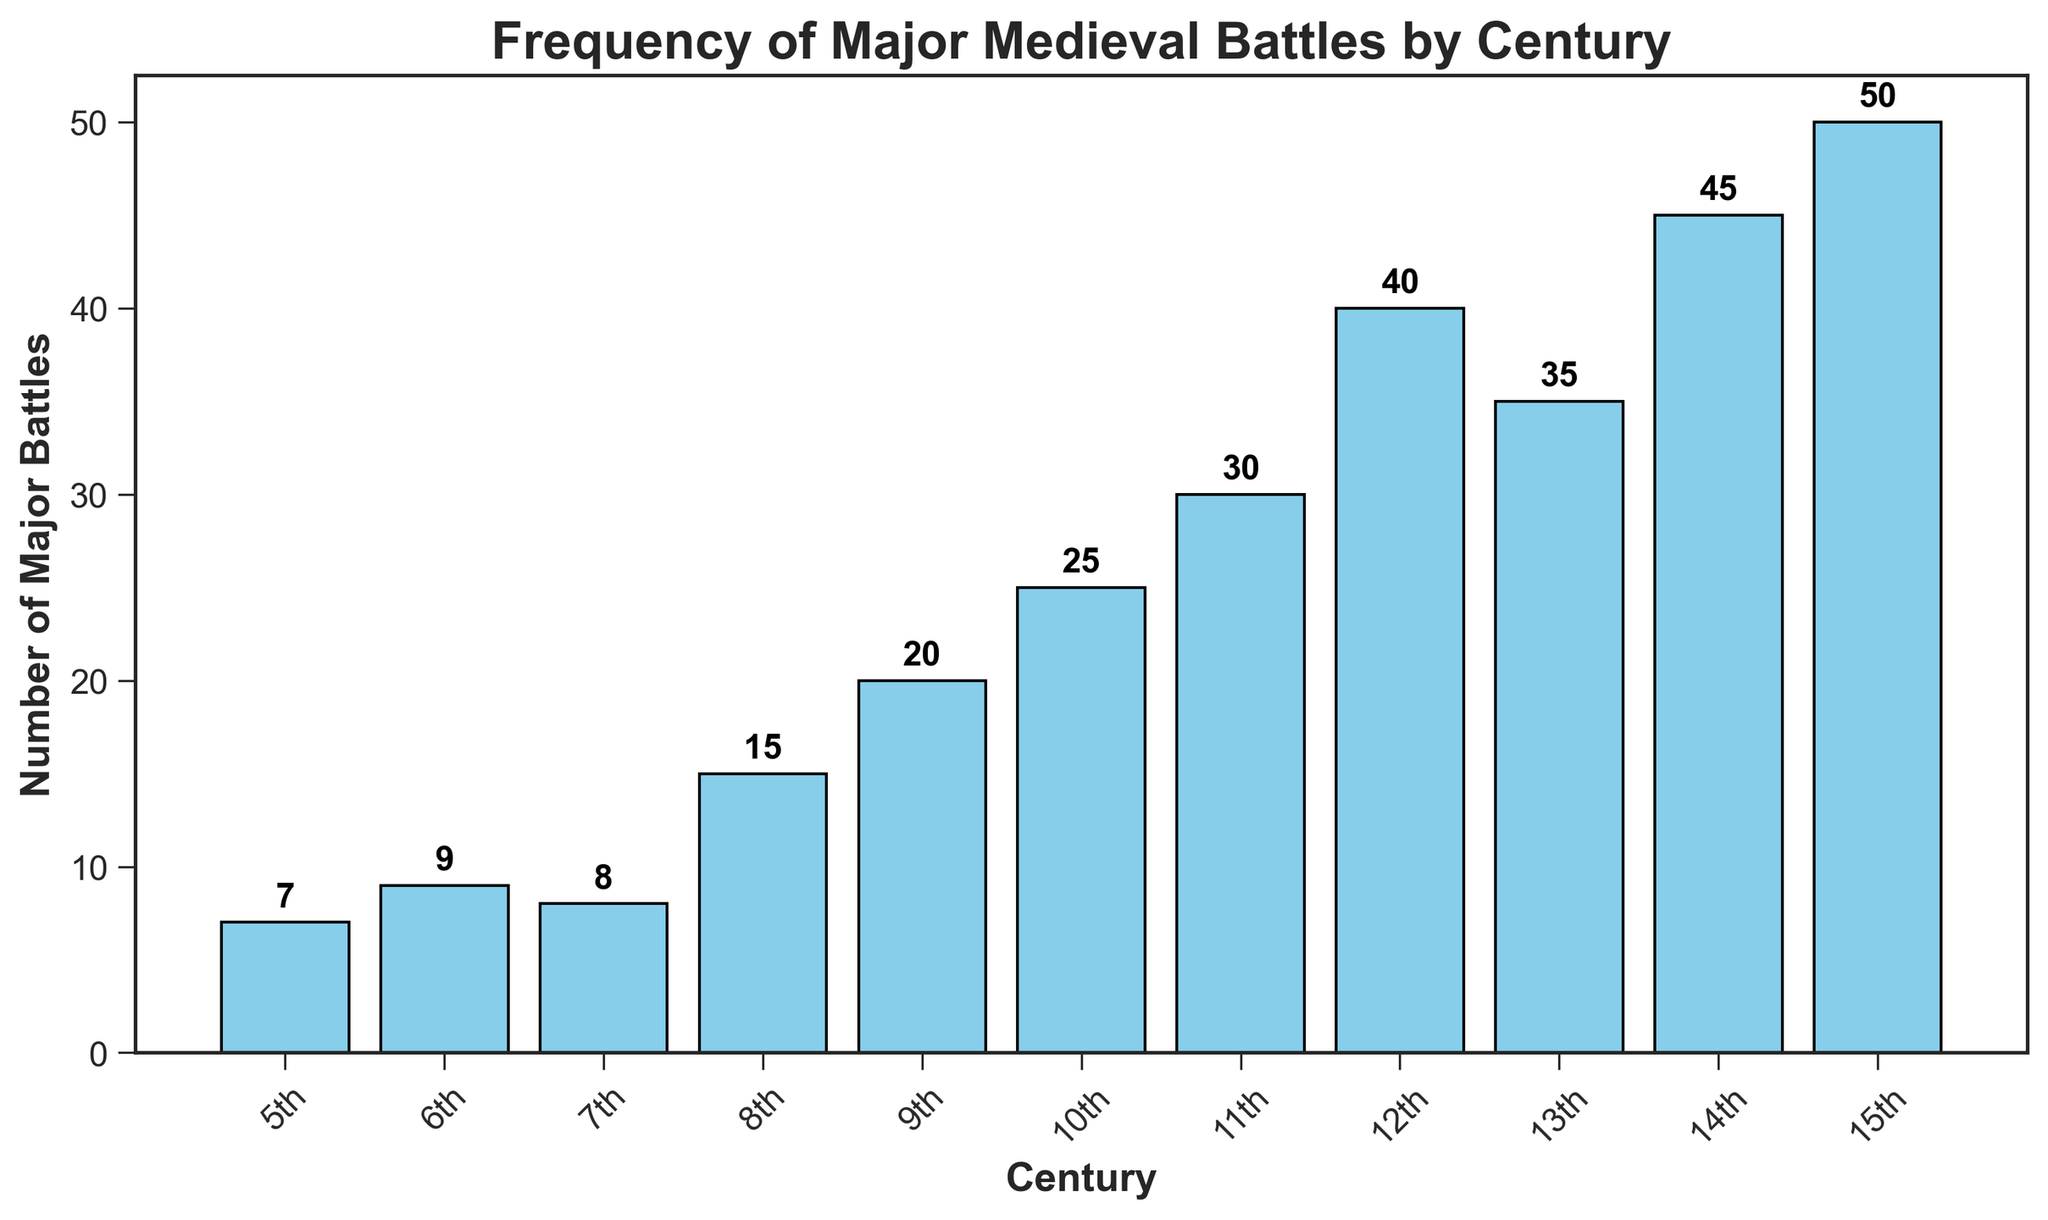Which century had the highest number of major battles? The 15th century had the highest bar in the chart with a value of 50, indicating it had the highest number of major battles.
Answer: 15th century How many more major battles were there in the 14th century compared to the 10th century? The 14th century had 45 major battles, and the 10th century had 25. Subtract 25 from 45 to find the difference: 45 - 25 = 20.
Answer: 20 Which century experienced fewer major battles: the 6th or the 8th? The 6th century had 9 major battles while the 8th century had 15 major battles. Since 9 is less than 15, the 6th century experienced fewer battles.
Answer: 6th century What is the total number of major battles from the 10th to the 12th century? Sum the number of battles in the 10th, 11th, and 12th centuries: 25 (10th) + 30 (11th) + 40 (12th) = 95.
Answer: 95 What is the approximate average number of major battles between the 5th and 7th centuries? Calculate the sum of battles in the 5th, 6th, and 7th centuries: 7 (5th) + 9 (6th) + 8 (7th) = 24. Then divide by 3: 24 / 3 = 8.
Answer: 8 Which two consecutive centuries had the greatest increase in the number of major battles? Comparing consecutive centuries: 
6th - 5th: 9 - 7 = 2
7th - 6th: 8 - 9 = -1
8th - 7th: 15 - 8 = 7
9th - 8th: 20 - 15 = 5
10th - 9th: 25 - 20 = 5
11th - 10th: 30 - 25 = 5
12th - 11th: 40 - 30 = 10
13th - 12th: 35 - 40 = -5
14th - 13th: 45 - 35 = 10
15th - 14th: 50 - 45 = 5
The greatest increase is 10, which occurred between the 11th and 12th centuries and again between the 13th and 14th centuries.
Answer: 11th to 12th and 13th to 14th centuries In which century did the frequency of major battles first exceed 30? The chart shows that the first century where the number of major battles exceeds 30 is the 11th century, with 30 battles.
Answer: 12th century How many centuries experienced fewer than 20 major battles? The 5th (7), 6th (9), 7th (8), and 8th (15) centuries all had fewer than 20 battles. There are 4 such centuries in total.
Answer: 4 What visual element helps to distinguish the highest frequency of major battles? The highest frequency is indicated by the tallest bar in the chart, which visually stands out compared to other bars.
Answer: Tallest bar What is the range in the number of major battles throughout the recorded centuries? The range is calculated by subtracting the minimum number of battles (7 in the 5th century) from the maximum number (50 in the 15th century): 50 - 7 = 43.
Answer: 43 